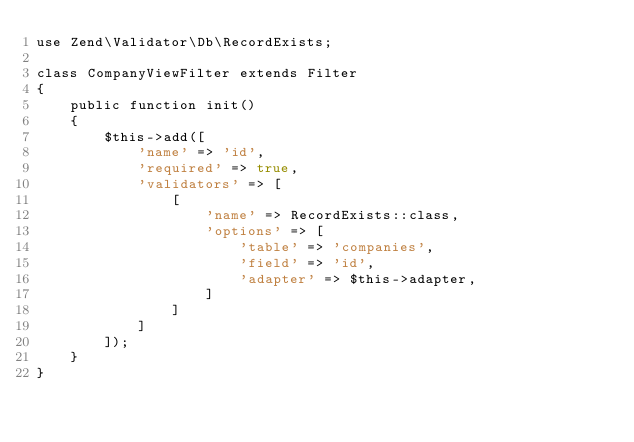Convert code to text. <code><loc_0><loc_0><loc_500><loc_500><_PHP_>use Zend\Validator\Db\RecordExists;

class CompanyViewFilter extends Filter
{
    public function init()
    {
        $this->add([
            'name' => 'id',
            'required' => true,
            'validators' => [
                [
                    'name' => RecordExists::class,
                    'options' => [
                        'table' => 'companies',
                        'field' => 'id',
                        'adapter' => $this->adapter,
                    ]
                ]
            ]
        ]);
    }
}</code> 